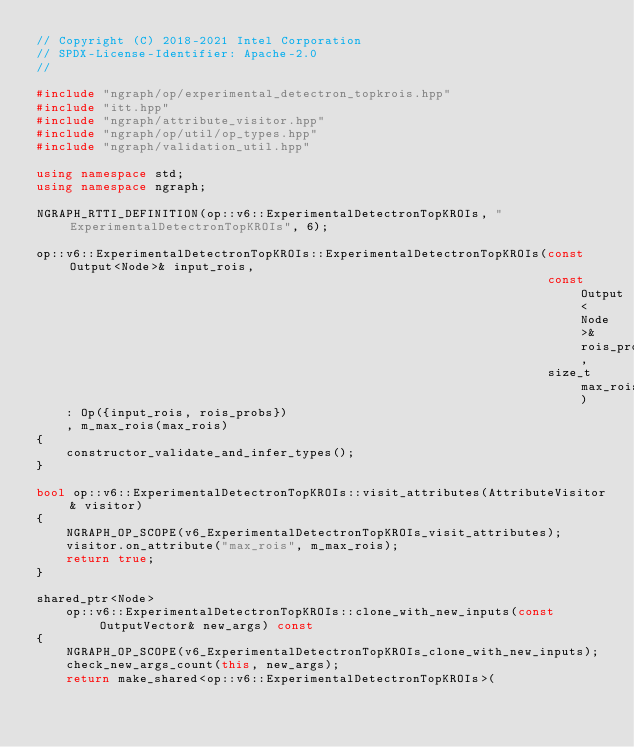Convert code to text. <code><loc_0><loc_0><loc_500><loc_500><_C++_>// Copyright (C) 2018-2021 Intel Corporation
// SPDX-License-Identifier: Apache-2.0
//

#include "ngraph/op/experimental_detectron_topkrois.hpp"
#include "itt.hpp"
#include "ngraph/attribute_visitor.hpp"
#include "ngraph/op/util/op_types.hpp"
#include "ngraph/validation_util.hpp"

using namespace std;
using namespace ngraph;

NGRAPH_RTTI_DEFINITION(op::v6::ExperimentalDetectronTopKROIs, "ExperimentalDetectronTopKROIs", 6);

op::v6::ExperimentalDetectronTopKROIs::ExperimentalDetectronTopKROIs(const Output<Node>& input_rois,
                                                                     const Output<Node>& rois_probs,
                                                                     size_t max_rois)
    : Op({input_rois, rois_probs})
    , m_max_rois(max_rois)
{
    constructor_validate_and_infer_types();
}

bool op::v6::ExperimentalDetectronTopKROIs::visit_attributes(AttributeVisitor& visitor)
{
    NGRAPH_OP_SCOPE(v6_ExperimentalDetectronTopKROIs_visit_attributes);
    visitor.on_attribute("max_rois", m_max_rois);
    return true;
}

shared_ptr<Node>
    op::v6::ExperimentalDetectronTopKROIs::clone_with_new_inputs(const OutputVector& new_args) const
{
    NGRAPH_OP_SCOPE(v6_ExperimentalDetectronTopKROIs_clone_with_new_inputs);
    check_new_args_count(this, new_args);
    return make_shared<op::v6::ExperimentalDetectronTopKROIs>(</code> 